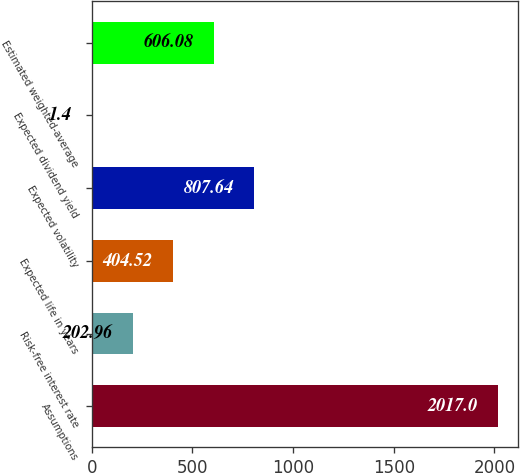Convert chart. <chart><loc_0><loc_0><loc_500><loc_500><bar_chart><fcel>Assumptions<fcel>Risk-free interest rate<fcel>Expected life in years<fcel>Expected volatility<fcel>Expected dividend yield<fcel>Estimated weighted-average<nl><fcel>2017<fcel>202.96<fcel>404.52<fcel>807.64<fcel>1.4<fcel>606.08<nl></chart> 